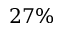Convert formula to latex. <formula><loc_0><loc_0><loc_500><loc_500>2 7 \%</formula> 